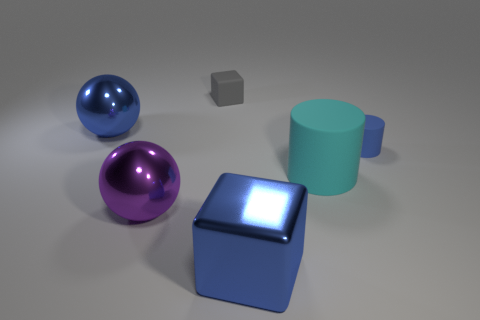What shape is the cyan thing?
Give a very brief answer. Cylinder. What number of big shiny objects are the same color as the large rubber cylinder?
Give a very brief answer. 0. There is a cyan rubber object that is the same size as the blue cube; what is its shape?
Make the answer very short. Cylinder. Are there any blue blocks of the same size as the gray matte object?
Make the answer very short. No. What material is the cylinder that is the same size as the gray matte block?
Offer a terse response. Rubber. What size is the cube behind the blue shiny object left of the gray matte block?
Offer a very short reply. Small. There is a matte cylinder in front of the blue rubber thing; is its size the same as the purple shiny thing?
Provide a succinct answer. Yes. Are there more blue objects behind the blue block than blue cylinders that are to the left of the large rubber object?
Provide a succinct answer. Yes. The blue thing that is on the left side of the cyan matte object and behind the large cyan rubber object has what shape?
Give a very brief answer. Sphere. What is the shape of the big blue thing behind the large cyan rubber object?
Ensure brevity in your answer.  Sphere. 